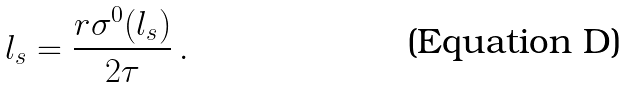Convert formula to latex. <formula><loc_0><loc_0><loc_500><loc_500>l _ { s } = \frac { r \sigma ^ { 0 } ( l _ { s } ) } { 2 \tau } \, .</formula> 